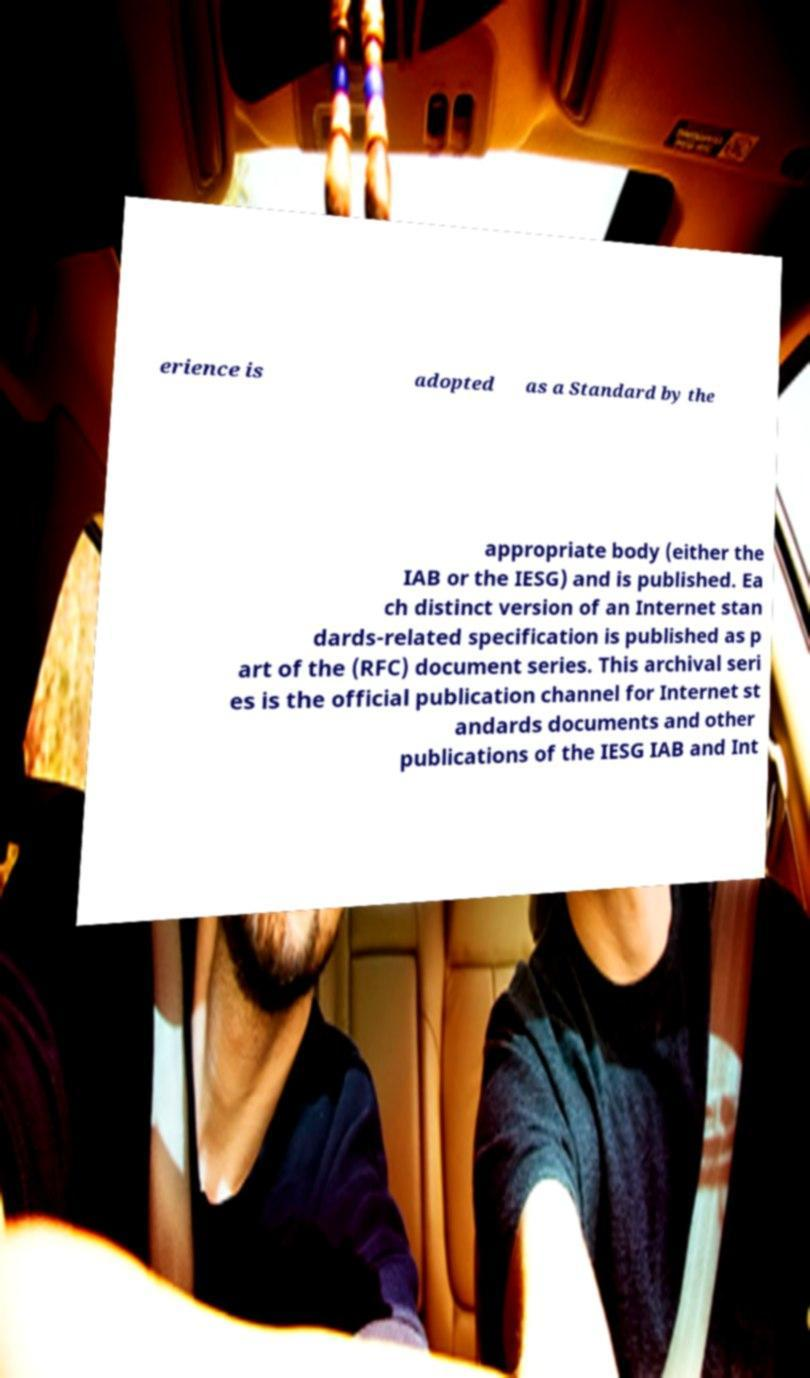I need the written content from this picture converted into text. Can you do that? erience is adopted as a Standard by the appropriate body (either the IAB or the IESG) and is published. Ea ch distinct version of an Internet stan dards-related specification is published as p art of the (RFC) document series. This archival seri es is the official publication channel for Internet st andards documents and other publications of the IESG IAB and Int 